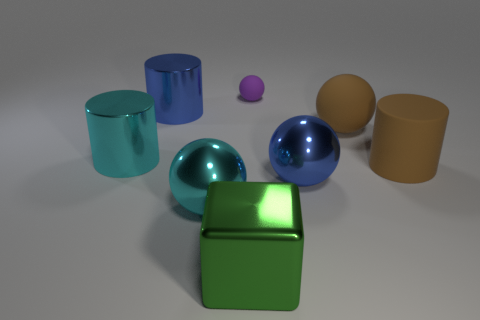What is the size of the rubber cylinder that is the same color as the large matte sphere?
Your answer should be compact. Large. There is a shiny thing that is right of the large cyan sphere and behind the large green shiny object; what is its size?
Ensure brevity in your answer.  Large. There is a blue object in front of the big cylinder that is on the right side of the blue shiny ball; what number of big cyan metallic objects are behind it?
Offer a terse response. 1. Are there any small rubber things of the same color as the block?
Your answer should be compact. No. There is a matte cylinder that is the same size as the block; what color is it?
Offer a terse response. Brown. There is a rubber thing that is behind the big rubber thing that is to the left of the cylinder to the right of the small purple rubber object; what is its shape?
Offer a terse response. Sphere. What number of large objects are in front of the large brown cylinder that is in front of the small purple sphere?
Offer a very short reply. 3. Do the blue object that is right of the metallic cube and the large blue metal thing behind the blue ball have the same shape?
Give a very brief answer. No. What number of metallic cylinders are in front of the big brown matte ball?
Offer a very short reply. 1. Do the big blue object that is on the left side of the metal cube and the purple object have the same material?
Ensure brevity in your answer.  No. 